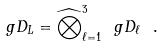<formula> <loc_0><loc_0><loc_500><loc_500>\ g D _ { L } = \widehat { \bigotimes } _ { \ell = 1 } ^ { 3 } \ g D _ { \ell } \ .</formula> 